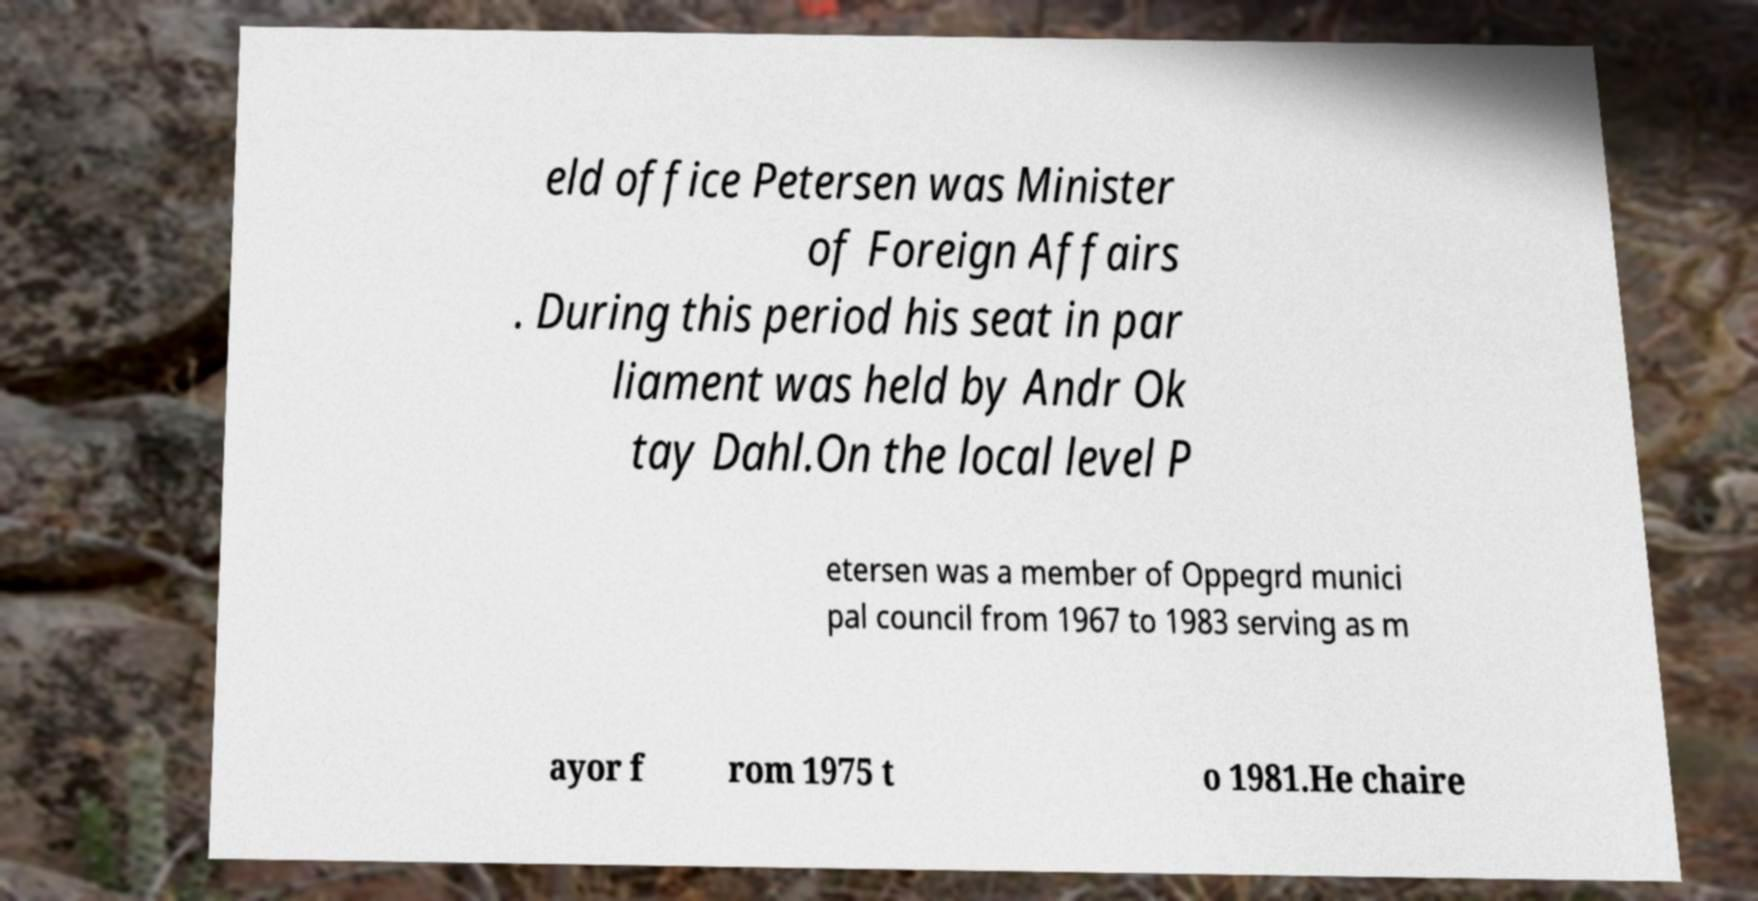Please identify and transcribe the text found in this image. eld office Petersen was Minister of Foreign Affairs . During this period his seat in par liament was held by Andr Ok tay Dahl.On the local level P etersen was a member of Oppegrd munici pal council from 1967 to 1983 serving as m ayor f rom 1975 t o 1981.He chaire 